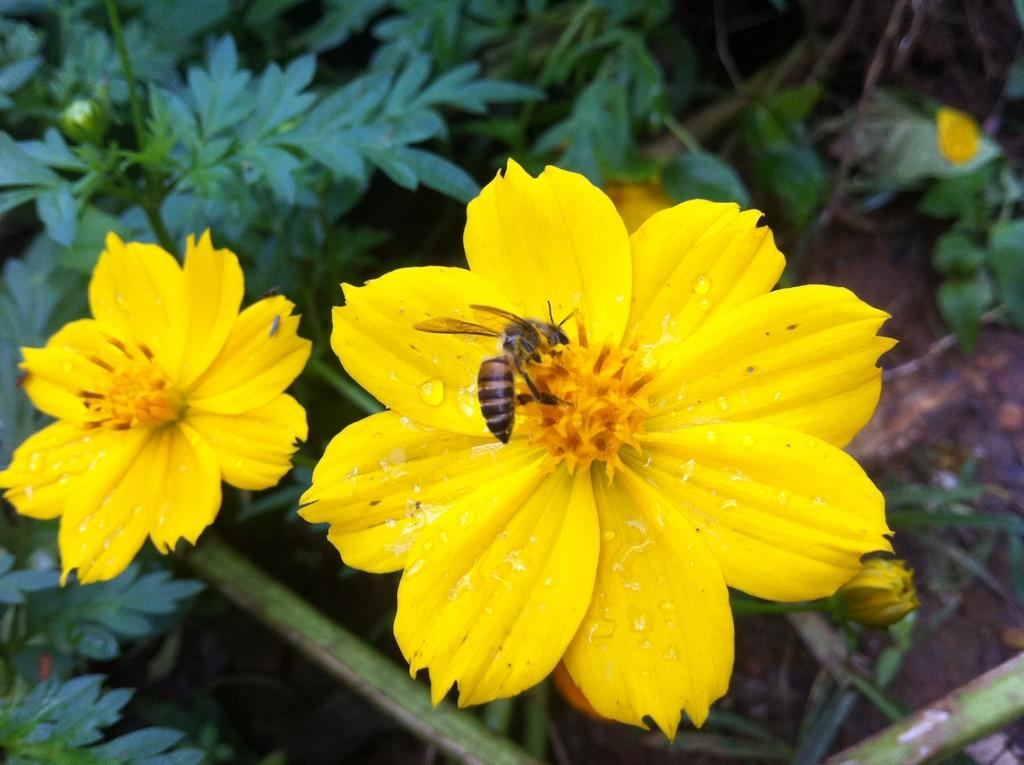What color are the flowers in the image? The flowers in the image are yellow. Is there any wildlife interacting with the flowers? Yes, a honey bee is present on one of the flowers. What can be seen in the background of the image? There are plants in the background of the image. Can you see any cabbage plants in the image? There is no cabbage plant present in the image; it features yellow flowers and a honey bee. Is there a cobweb visible in the image? There is no cobweb visible in the image; it focuses on flowers, a honey bee, and plants in the background. 